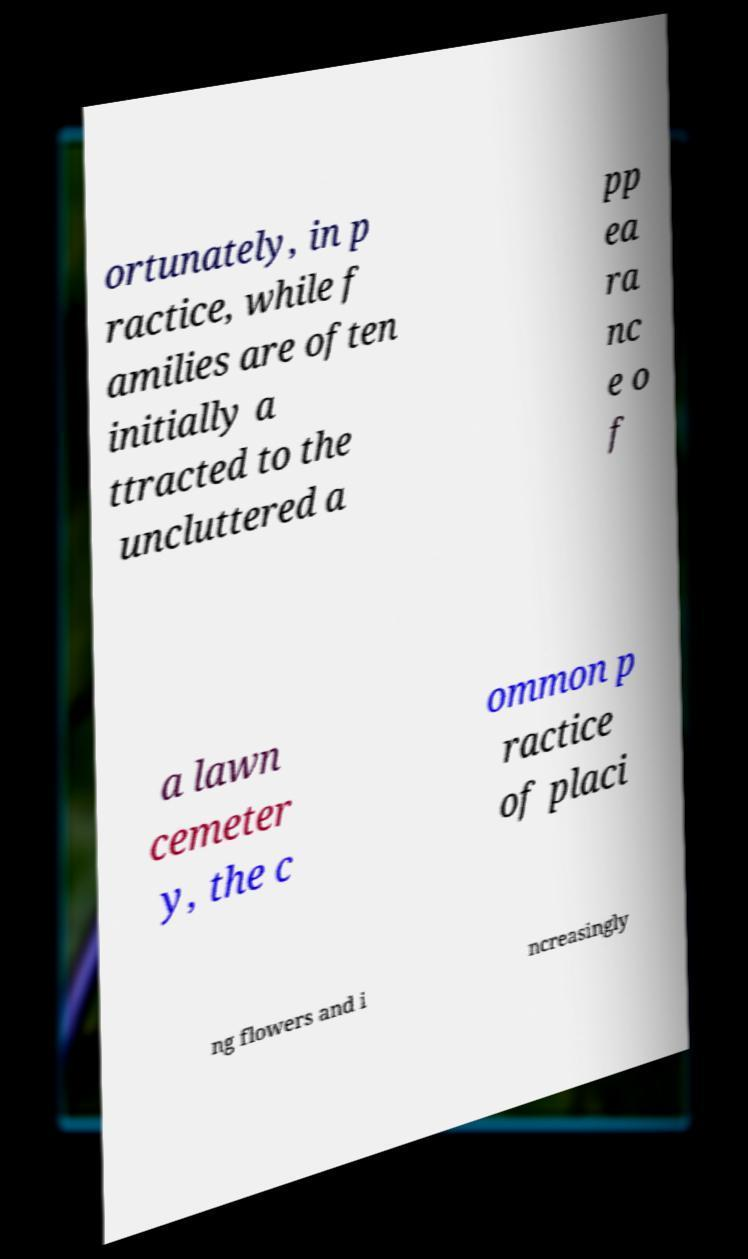Can you accurately transcribe the text from the provided image for me? ortunately, in p ractice, while f amilies are often initially a ttracted to the uncluttered a pp ea ra nc e o f a lawn cemeter y, the c ommon p ractice of placi ng flowers and i ncreasingly 